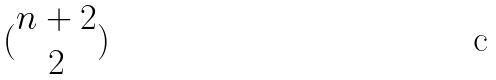Convert formula to latex. <formula><loc_0><loc_0><loc_500><loc_500>( \begin{matrix} n + 2 \\ 2 \end{matrix} )</formula> 